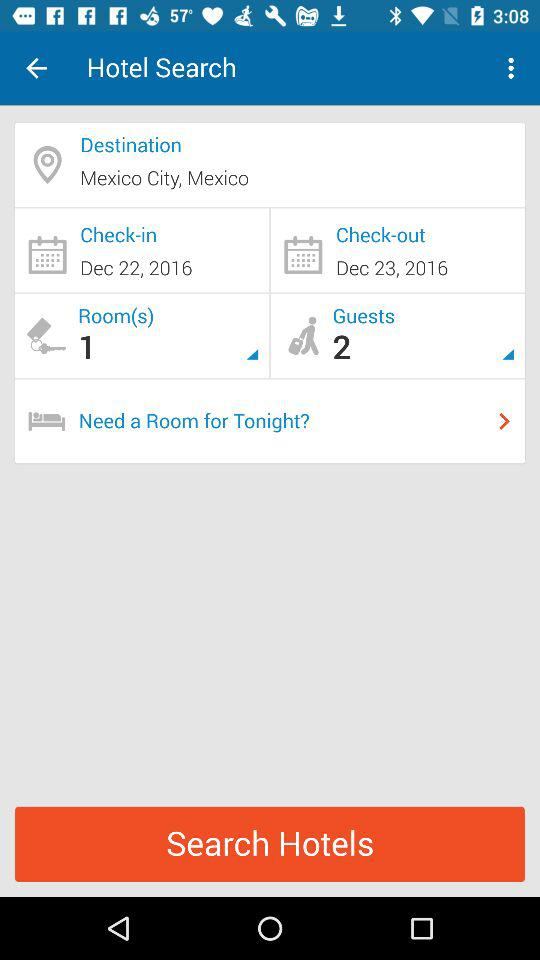What is the check-out date? The check-out date is December 23, 2016. 